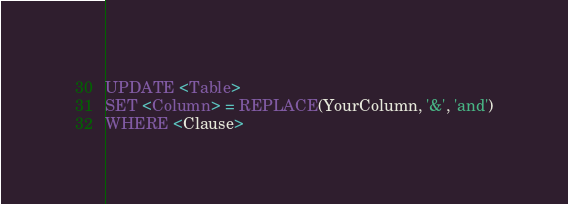Convert code to text. <code><loc_0><loc_0><loc_500><loc_500><_SQL_>UPDATE <Table>
SET <Column> = REPLACE(YourColumn, '&', 'and')
WHERE <Clause>
</code> 